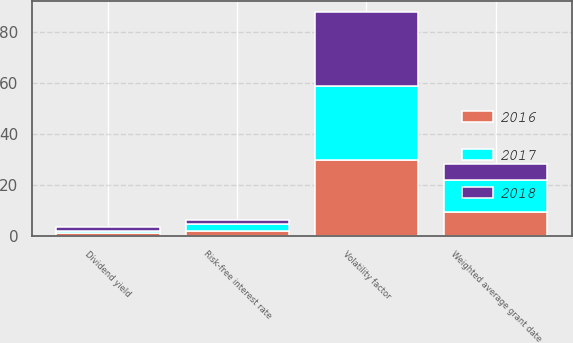Convert chart. <chart><loc_0><loc_0><loc_500><loc_500><stacked_bar_chart><ecel><fcel>Weighted average grant date<fcel>Risk-free interest rate<fcel>Dividend yield<fcel>Volatility factor<nl><fcel>2017<fcel>12.34<fcel>2.72<fcel>1.02<fcel>29<nl><fcel>2016<fcel>9.68<fcel>2.16<fcel>1.19<fcel>30<nl><fcel>2018<fcel>6.43<fcel>1.41<fcel>1.49<fcel>29<nl></chart> 